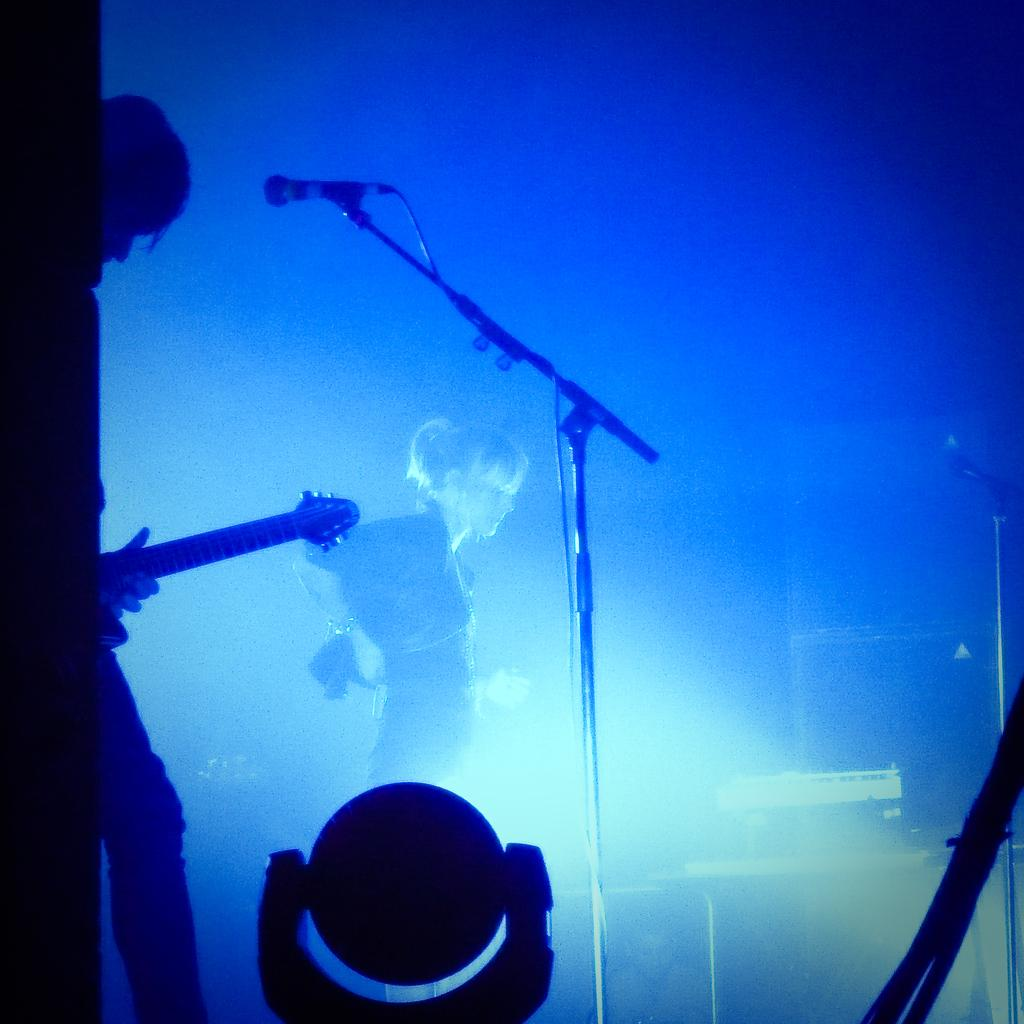What is the man in the foreground of the image holding? The man is holding a guitar in the foreground of the image. What is the woman in the background of the image doing? The woman is standing in the background of the image. What is in front of the man holding the guitar? There is a microphone in front of the man. Can you describe the light at the bottom of the image? There is a light at the bottom of the image. What type of room can be seen in the image? There is no specific room visible in the image. 